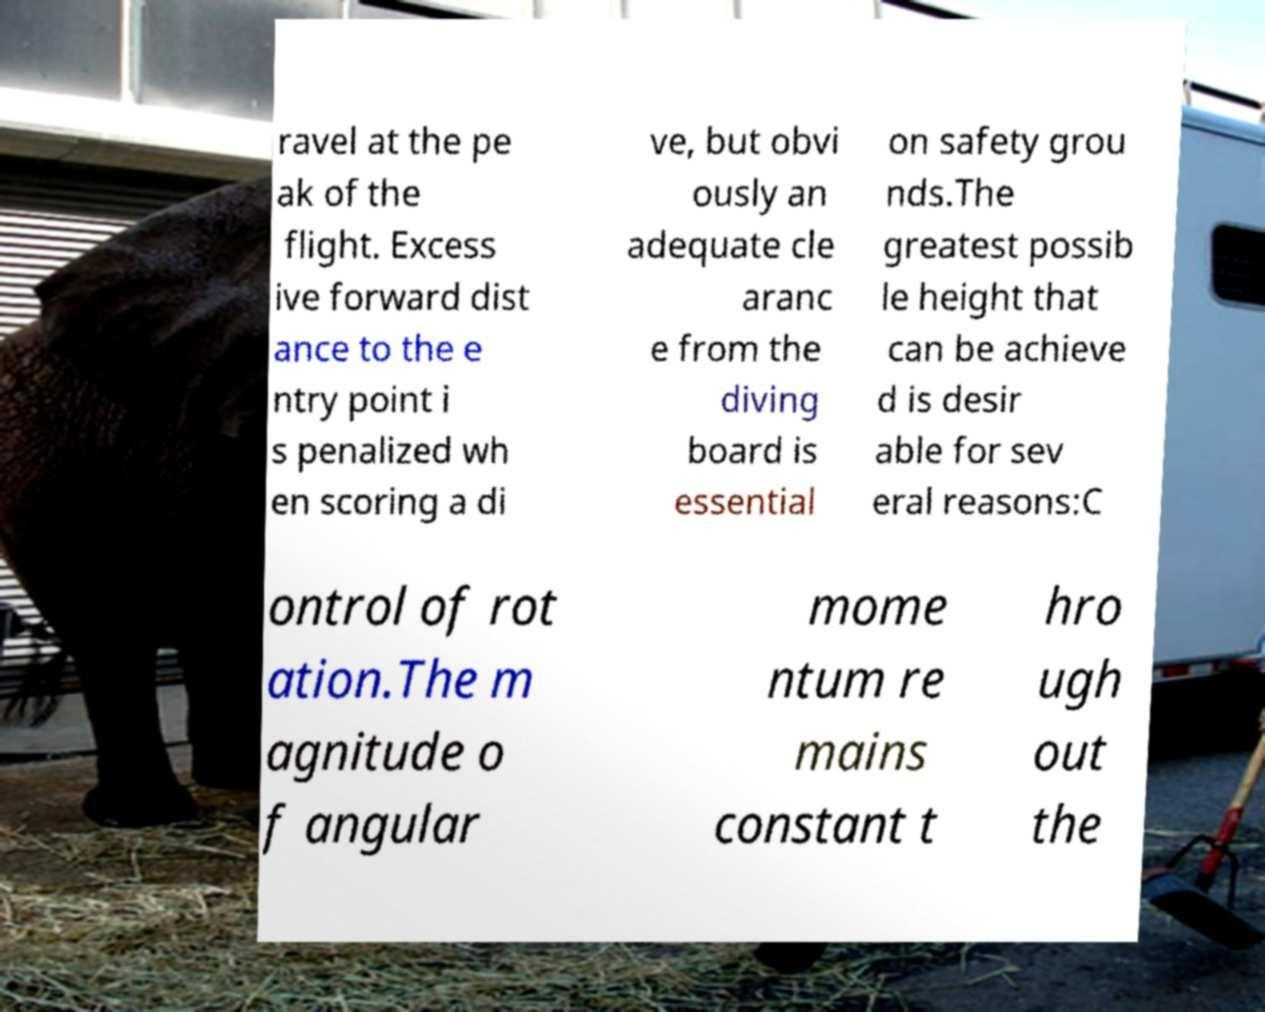What messages or text are displayed in this image? I need them in a readable, typed format. ravel at the pe ak of the flight. Excess ive forward dist ance to the e ntry point i s penalized wh en scoring a di ve, but obvi ously an adequate cle aranc e from the diving board is essential on safety grou nds.The greatest possib le height that can be achieve d is desir able for sev eral reasons:C ontrol of rot ation.The m agnitude o f angular mome ntum re mains constant t hro ugh out the 